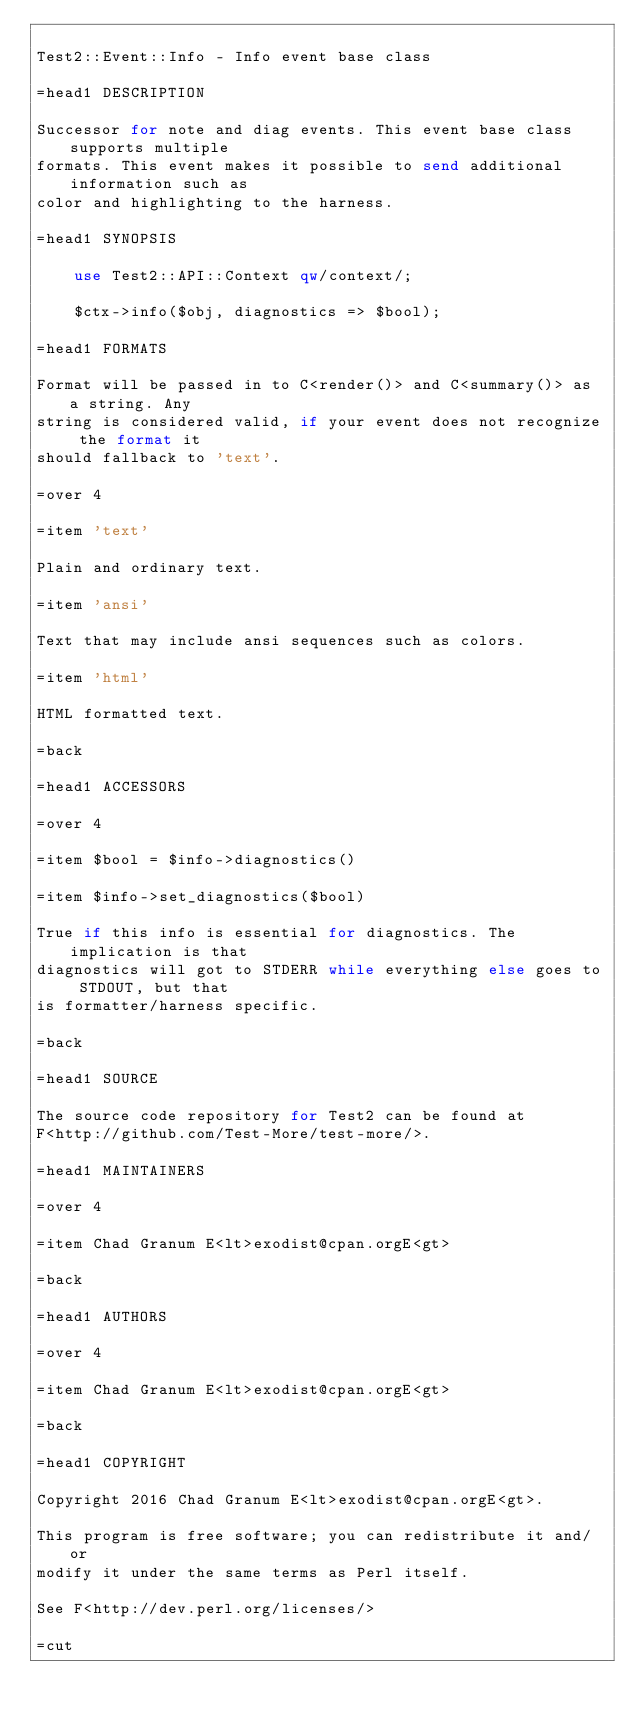Convert code to text. <code><loc_0><loc_0><loc_500><loc_500><_Perl_>
Test2::Event::Info - Info event base class

=head1 DESCRIPTION

Successor for note and diag events. This event base class supports multiple
formats. This event makes it possible to send additional information such as
color and highlighting to the harness.

=head1 SYNOPSIS

    use Test2::API::Context qw/context/;

    $ctx->info($obj, diagnostics => $bool);

=head1 FORMATS

Format will be passed in to C<render()> and C<summary()> as a string. Any
string is considered valid, if your event does not recognize the format it
should fallback to 'text'.

=over 4

=item 'text'

Plain and ordinary text.

=item 'ansi'

Text that may include ansi sequences such as colors.

=item 'html'

HTML formatted text.

=back

=head1 ACCESSORS

=over 4

=item $bool = $info->diagnostics()

=item $info->set_diagnostics($bool)

True if this info is essential for diagnostics. The implication is that
diagnostics will got to STDERR while everything else goes to STDOUT, but that
is formatter/harness specific.

=back

=head1 SOURCE

The source code repository for Test2 can be found at
F<http://github.com/Test-More/test-more/>.

=head1 MAINTAINERS

=over 4

=item Chad Granum E<lt>exodist@cpan.orgE<gt>

=back

=head1 AUTHORS

=over 4

=item Chad Granum E<lt>exodist@cpan.orgE<gt>

=back

=head1 COPYRIGHT

Copyright 2016 Chad Granum E<lt>exodist@cpan.orgE<gt>.

This program is free software; you can redistribute it and/or
modify it under the same terms as Perl itself.

See F<http://dev.perl.org/licenses/>

=cut
</code> 